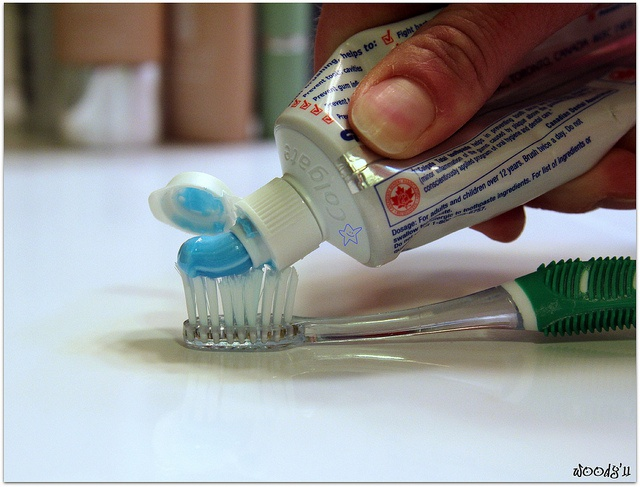Describe the objects in this image and their specific colors. I can see people in white, maroon, black, and brown tones and toothbrush in white, gray, black, darkgray, and darkgreen tones in this image. 